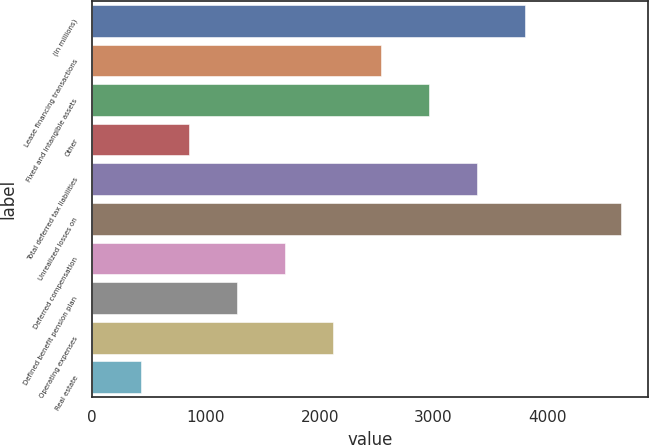<chart> <loc_0><loc_0><loc_500><loc_500><bar_chart><fcel>(In millions)<fcel>Lease financing transactions<fcel>Fixed and intangible assets<fcel>Other<fcel>Total deferred tax liabilities<fcel>Unrealized losses on<fcel>Deferred compensation<fcel>Defined benefit pension plan<fcel>Operating expenses<fcel>Real estate<nl><fcel>3805.8<fcel>2539.2<fcel>2961.4<fcel>850.4<fcel>3383.6<fcel>4650.2<fcel>1694.8<fcel>1272.6<fcel>2117<fcel>428.2<nl></chart> 